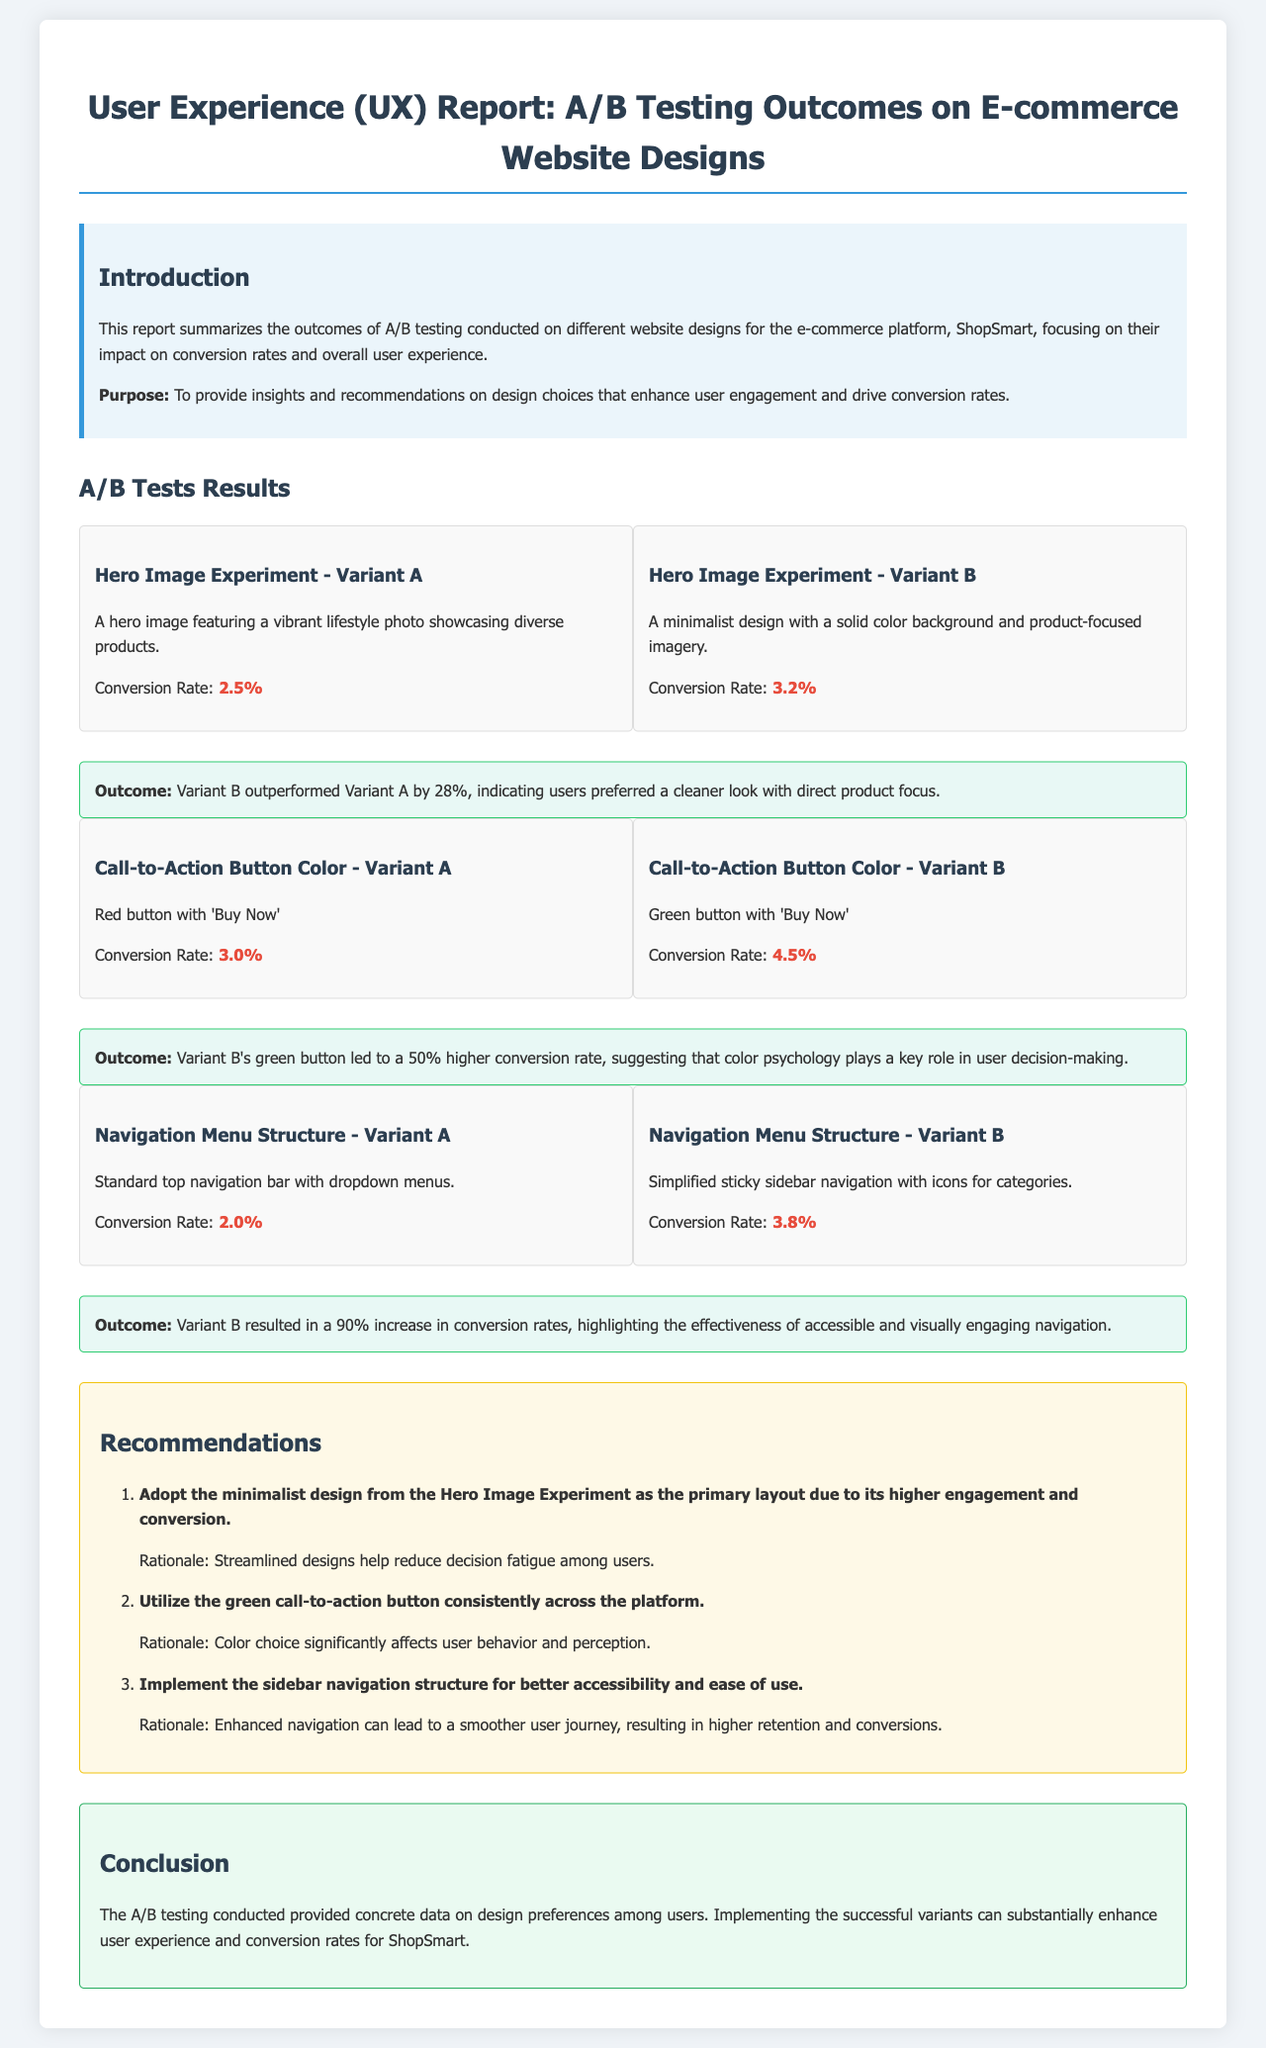What were the conversion rates for Variant A and Variant B in the Hero Image Experiment? The conversion rates for Variant A is 2.5% and for Variant B is 3.2%.
Answer: 2.5%, 3.2% Which variant in the Call-to-Action Button Color test had a higher conversion rate? Variant B with a conversion rate of 4.5% had a higher conversion rate than Variant A.
Answer: Variant B How much higher was the conversion rate of Variant B compared to Variant A in the Navigation Menu Structure test? Variant B had a conversion rate of 3.8%, while Variant A had 2.0%, which indicates a 90% increase.
Answer: 90% What design approach is recommended for the Hero Image Experiment? The recommendation is to adopt the minimalist design for better engagement and conversion.
Answer: Minimalist design What outcome was recorded for the Call-to-Action Button Color test? The outcome was that Variant B’s green button led to a 50% higher conversion rate.
Answer: 50% higher conversion rate What is the main conclusion from the A/B testing conducted? The conclusion highlights that implementing successful variants can enhance user experience and conversion rates.
Answer: Enhance user experience and conversion rates How many recommendations are provided in the report? The report includes three recommendations based on the testing outcomes.
Answer: Three recommendations What types of improvements are suggested for usability based on the navigation structure results? The report suggests implementing the sidebar navigation for better accessibility and ease of use.
Answer: Sidebar navigation What did the Hero Image Experiment achieve in terms of Variant B's performance over Variant A? Variant B outperformed Variant A by 28% indicating user preference for cleaner designs.
Answer: 28% 